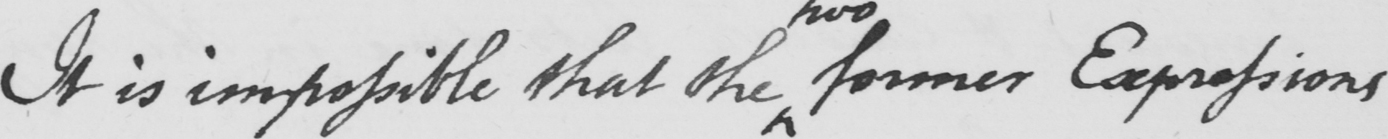What does this handwritten line say? It is impossible that the former Expressions 